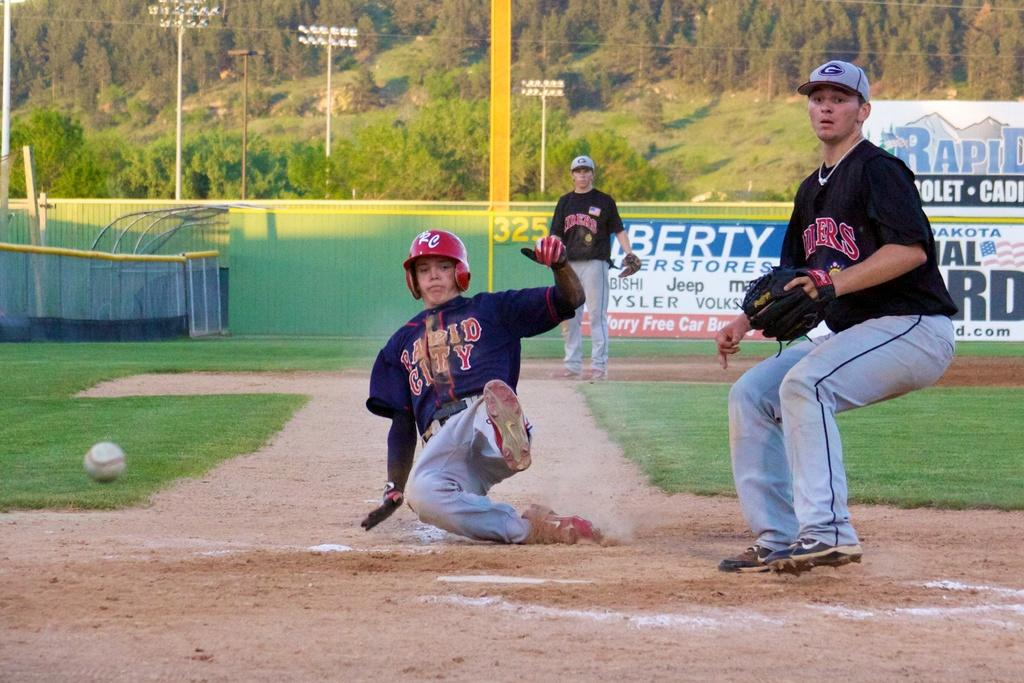<image>
Give a short and clear explanation of the subsequent image. A baseball player for Rapid City is trying to slide into base before the player at the base catches the ball to tag him out. 